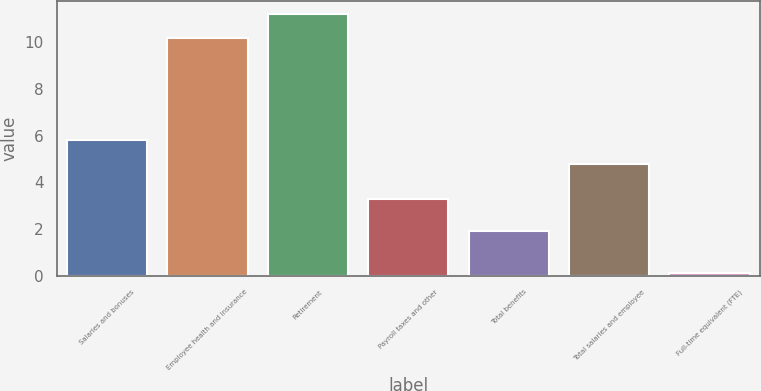<chart> <loc_0><loc_0><loc_500><loc_500><bar_chart><fcel>Salaries and bonuses<fcel>Employee health and insurance<fcel>Retirement<fcel>Payroll taxes and other<fcel>Total benefits<fcel>Total salaries and employee<fcel>Full-time equivalent (FTE)<nl><fcel>5.82<fcel>10.2<fcel>11.22<fcel>3.3<fcel>1.9<fcel>4.8<fcel>0.1<nl></chart> 